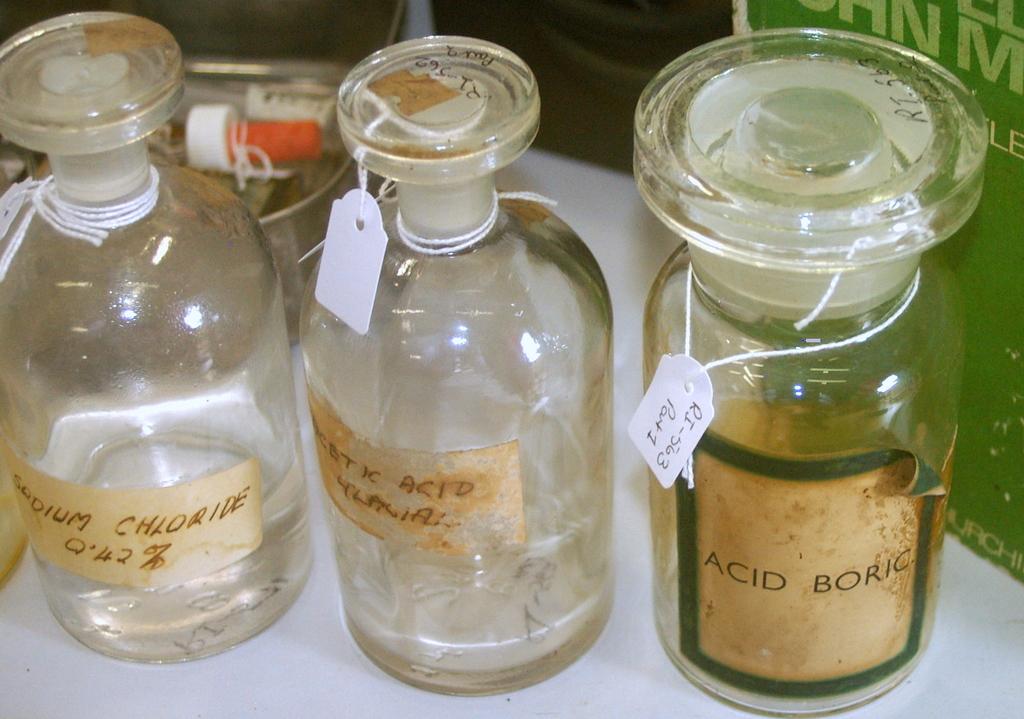What is the label on the bottle in green?
Ensure brevity in your answer.  Acid boric. 